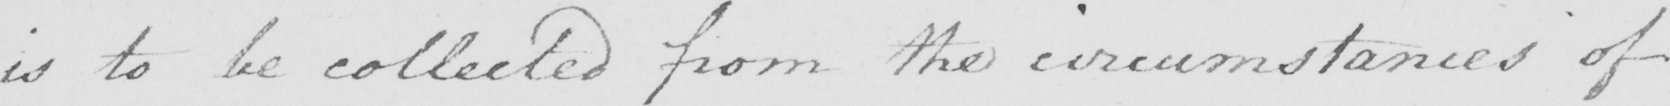Can you tell me what this handwritten text says? is to be collected from the circumstances of 